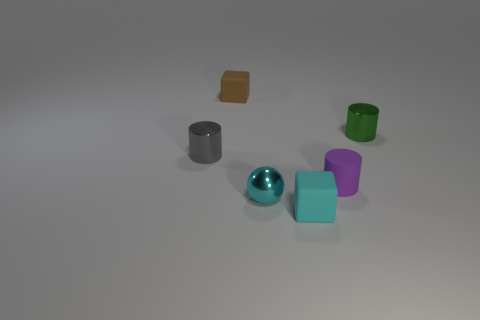Add 4 red objects. How many objects exist? 10 Subtract all balls. How many objects are left? 5 Subtract 0 purple spheres. How many objects are left? 6 Subtract all tiny rubber objects. Subtract all big red shiny cubes. How many objects are left? 3 Add 3 gray cylinders. How many gray cylinders are left? 4 Add 6 green shiny cylinders. How many green shiny cylinders exist? 7 